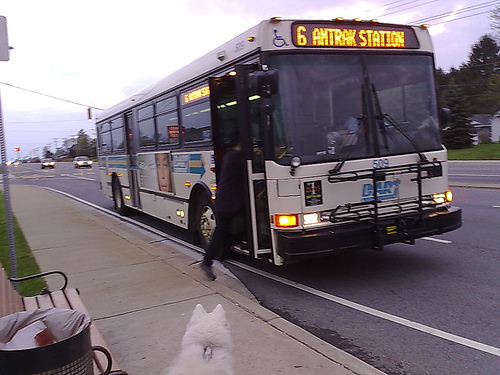Describe the type and condition of the bus seen in the image. The bus is a standard city transit model featuring a front-facing digital display indicating its route to Amtrak Station. It exhibits moderate wear typical for public service vehicles, including slight cosmetic blemishes around the edges but maintains a clean, functional aspect overall. 